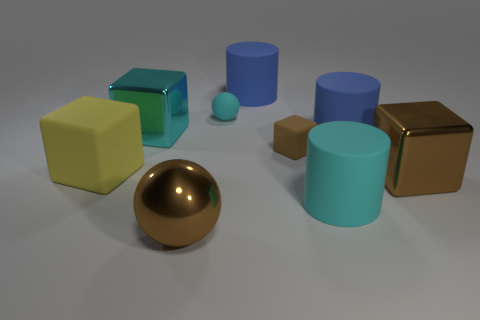How many brown shiny things have the same size as the yellow matte cube?
Give a very brief answer. 2. What is the shape of the large yellow thing?
Make the answer very short. Cube. How big is the rubber cylinder that is behind the large matte cube and in front of the large cyan cube?
Provide a succinct answer. Large. There is a cylinder to the left of the tiny brown matte block; what is it made of?
Provide a succinct answer. Rubber. There is a small ball; does it have the same color as the metallic object that is to the left of the big brown sphere?
Keep it short and to the point. Yes. What number of objects are either big objects in front of the big cyan block or big blue rubber cylinders on the right side of the big cyan cylinder?
Keep it short and to the point. 5. The matte thing that is both behind the large cyan cube and on the right side of the tiny cyan thing is what color?
Give a very brief answer. Blue. Is the number of yellow metallic objects greater than the number of big brown objects?
Ensure brevity in your answer.  No. There is a big thing that is behind the big cyan block; does it have the same shape as the tiny brown thing?
Offer a terse response. No. What number of matte objects are big green balls or blue cylinders?
Ensure brevity in your answer.  2. 